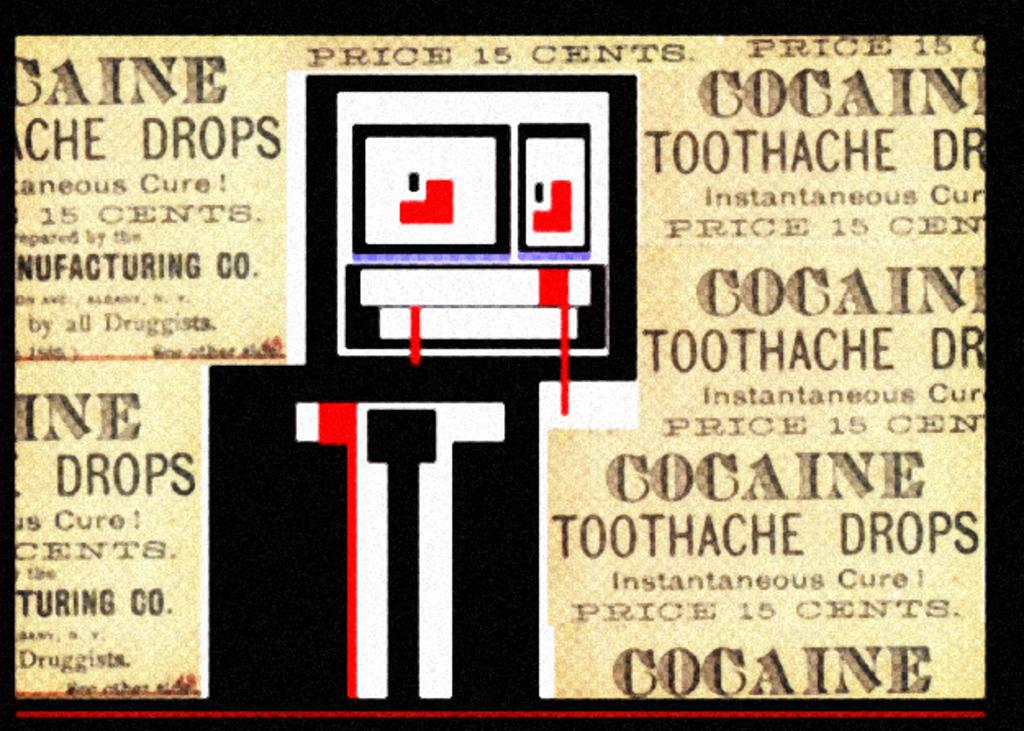<image>
Present a compact description of the photo's key features. A disturbing right bit character with blood coming out its eyes and the word cocaine surrounding it. 